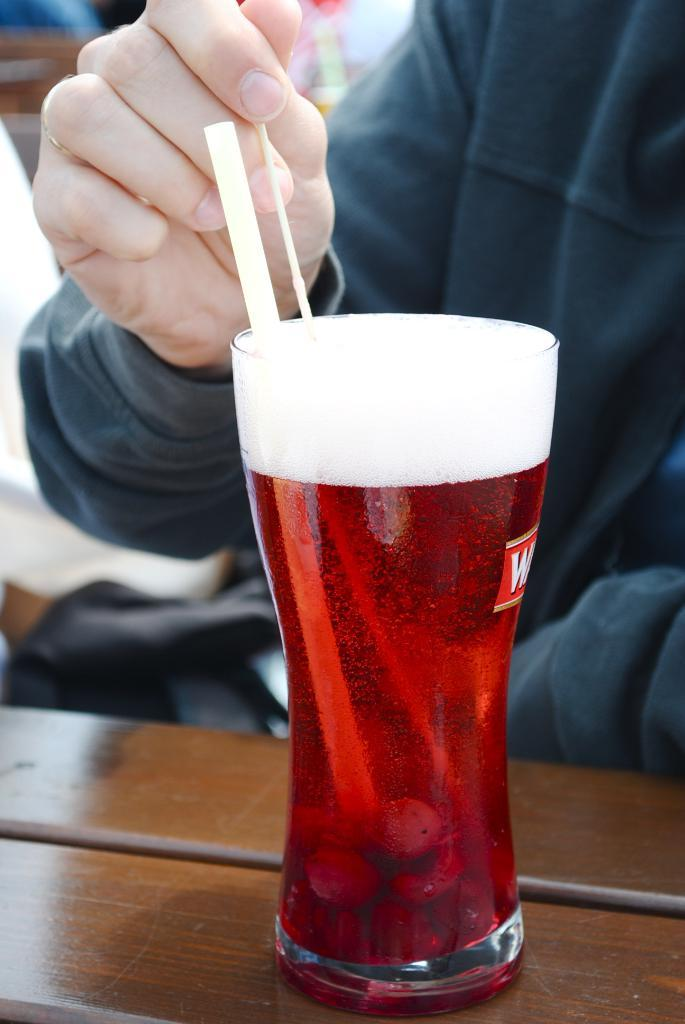What is inside the glass that has a straw in it? There is no specific information about what is inside the glass, but it has a straw in it. What is the person holding in the image? One person is holding something, but the specific object is not mentioned in the facts. What is the color of the surface the glass is on? The glass is on a brown color surface. How many yams are being attacked by the goose in the image? There is no goose or yam present in the image. What type of attack is the goose performing on the yam in the image? There is no goose or yam present in the image, so no such attack can be observed. 